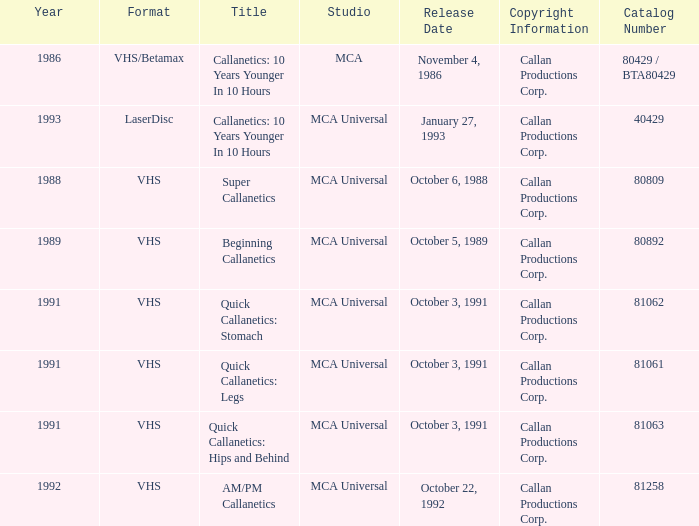Name the format for  quick callanetics: hips and behind VHS. 